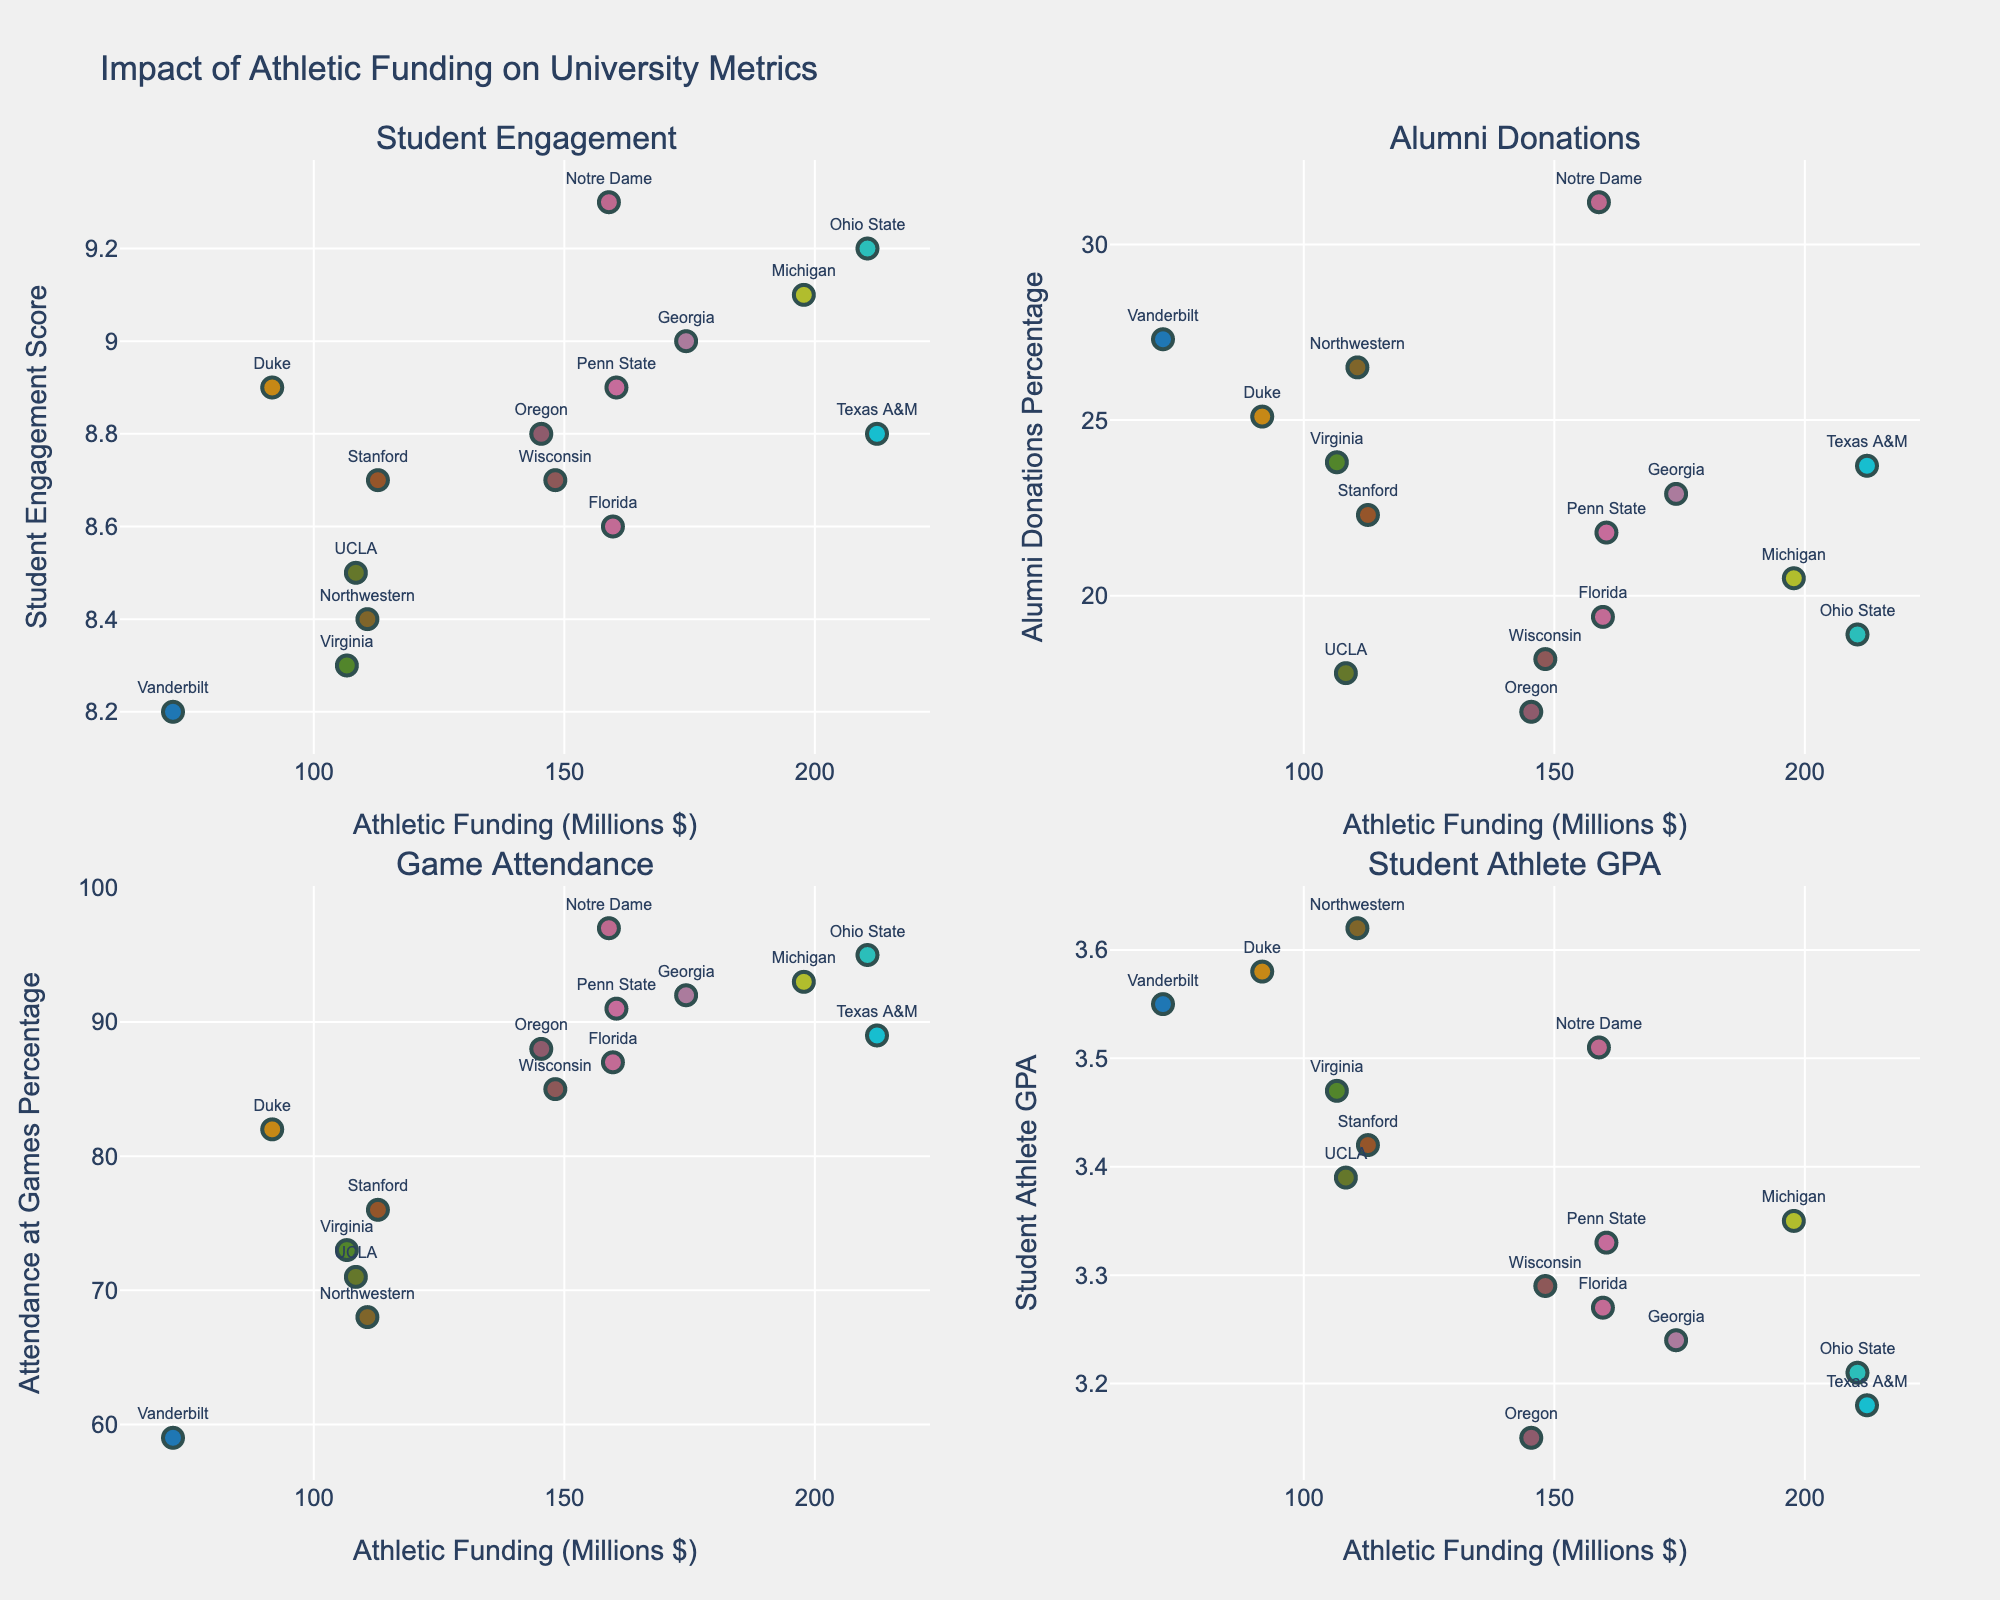what is the title of the figure? The title of the figure is generally at the top center and it usually summarizes what the plot is about.
Answer: Impact of Athletic Funding on University Metrics Which metric has the highest data point for athletic funding? We need to look at all four subplots and identify the one with the highest Athletic Funding value on the x-axis.
Answer: Game Attendance Which university has the lowest athletic funding? From the x-axis of any subplot, locate the data point with the lowest value and refer to its associated text label.
Answer: Vanderbilt Which university scores the highest in Student Engagement Score? Look at the subplot titled "Student Engagement" and find the highest value on the y-axis, then see its corresponding university.
Answer: Notre Dame What is the average Student Athlete GPA across universities? Sum up all the Student Athlete GPA values and divide by the number of universities (15).
Answer: 3.36 Compare alumni donations percentage for the university with the highest and lowest athletic funding. Identify the universities with the highest and lowest athletic funding and compare their y-axis values in the Alumni Donations subplot.
Answer: Vanderbilt (27.3%) has higher than Texas A&M (23.7%) Does higher athletic funding generally correlate with higher game attendance? Observe the overall trend of the data points in the Game Attendance subplot to see if they increase with athletic funding.
Answer: Yes Which subplot shows the least variation in y-values? Look at the range of y-values in each subplot and identify the one with the smallest range.
Answer: Student Athlete GPA How does Stanford’s Student Engagement Score compare to that of Notre Dame? Locate both universities in the Student Engagement subplot and compare their y-axis values.
Answer: Stanford has a lower score than Notre Dame Which university has the highest student-athlete GPA and what is their athletic funding? Locate the university with the highest y-value in the "Student Athlete GPA" subplot and read its x-axis value.
Answer: Northwestern, $110.7 million 